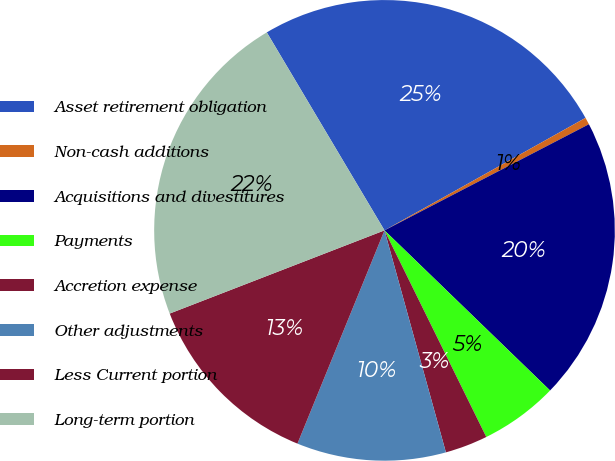<chart> <loc_0><loc_0><loc_500><loc_500><pie_chart><fcel>Asset retirement obligation<fcel>Non-cash additions<fcel>Acquisitions and divestitures<fcel>Payments<fcel>Accretion expense<fcel>Other adjustments<fcel>Less Current portion<fcel>Long-term portion<nl><fcel>25.41%<fcel>0.5%<fcel>19.85%<fcel>5.48%<fcel>2.99%<fcel>10.46%<fcel>12.95%<fcel>22.34%<nl></chart> 